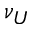<formula> <loc_0><loc_0><loc_500><loc_500>\nu _ { U }</formula> 